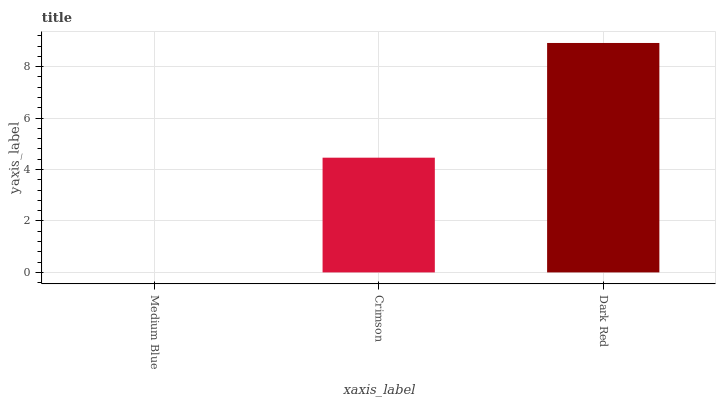Is Medium Blue the minimum?
Answer yes or no. Yes. Is Dark Red the maximum?
Answer yes or no. Yes. Is Crimson the minimum?
Answer yes or no. No. Is Crimson the maximum?
Answer yes or no. No. Is Crimson greater than Medium Blue?
Answer yes or no. Yes. Is Medium Blue less than Crimson?
Answer yes or no. Yes. Is Medium Blue greater than Crimson?
Answer yes or no. No. Is Crimson less than Medium Blue?
Answer yes or no. No. Is Crimson the high median?
Answer yes or no. Yes. Is Crimson the low median?
Answer yes or no. Yes. Is Dark Red the high median?
Answer yes or no. No. Is Medium Blue the low median?
Answer yes or no. No. 